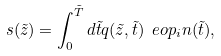<formula> <loc_0><loc_0><loc_500><loc_500>s ( \tilde { z } ) = \int _ { 0 } ^ { \tilde { T } } d \tilde { t } q ( \tilde { z } , \tilde { t } ) \ e o p _ { i } n ( \tilde { t } ) ,</formula> 